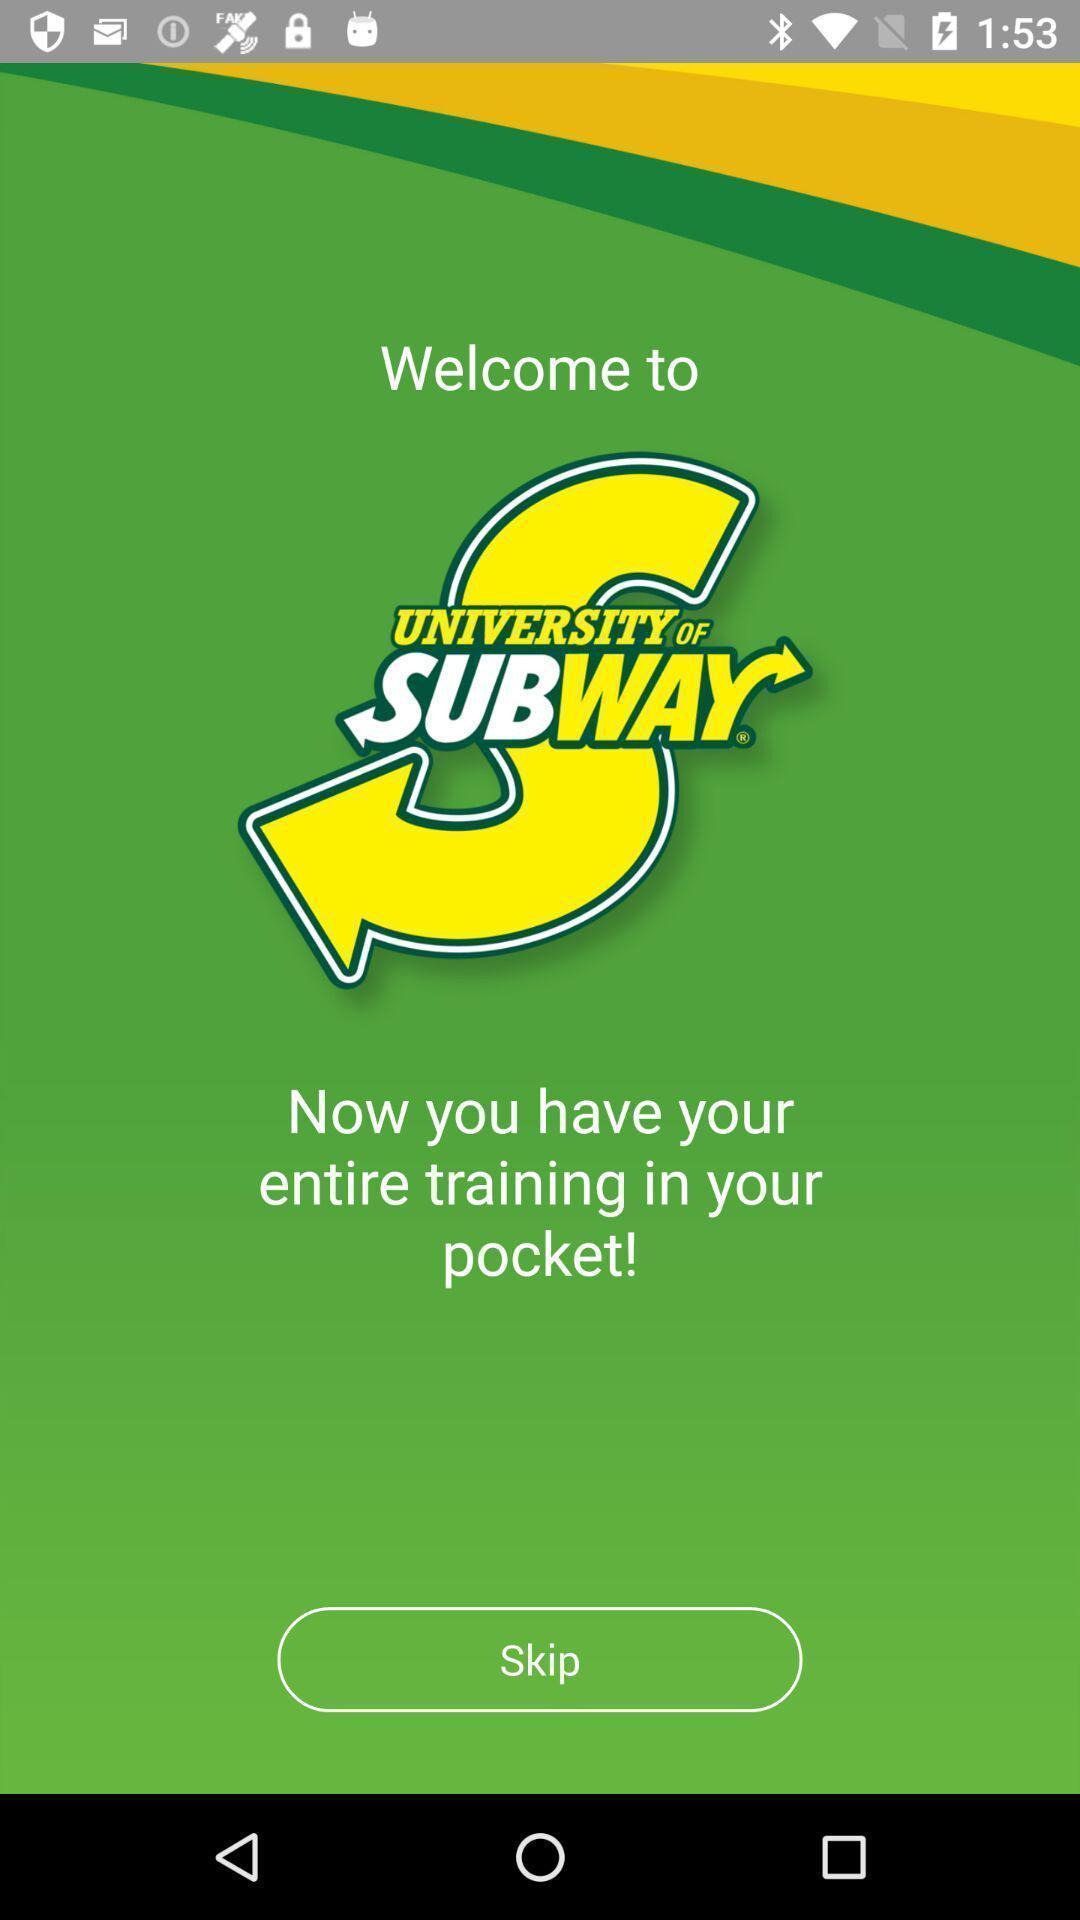Provide a detailed account of this screenshot. Welcome page of sub way app. 